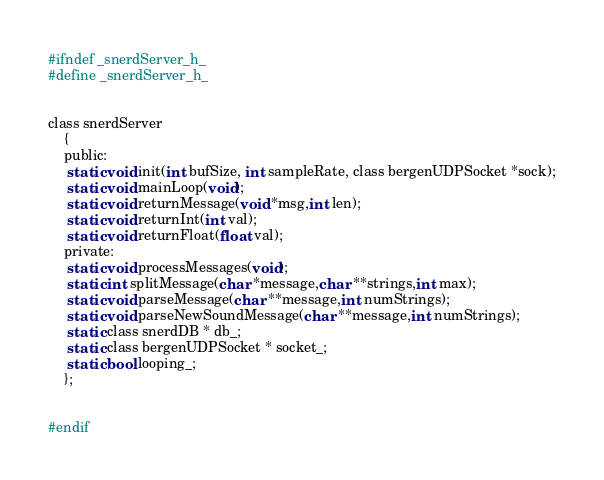Convert code to text. <code><loc_0><loc_0><loc_500><loc_500><_C_>#ifndef _snerdServer_h_
#define _snerdServer_h_


class snerdServer
	{
	public:
	 static void init(int bufSize, int sampleRate, class bergenUDPSocket *sock);
	 static void mainLoop(void);
	 static void returnMessage(void *msg,int len);
	 static void returnInt(int val);
	 static void returnFloat(float val);
	private:
	 static void processMessages(void);
	 static int splitMessage(char *message,char **strings,int max);
	 static void parseMessage(char **message,int numStrings);
	 static void parseNewSoundMessage(char **message,int numStrings);
	 static class snerdDB * db_;
	 static class bergenUDPSocket * socket_;
	 static bool looping_;
	};


#endif
</code> 